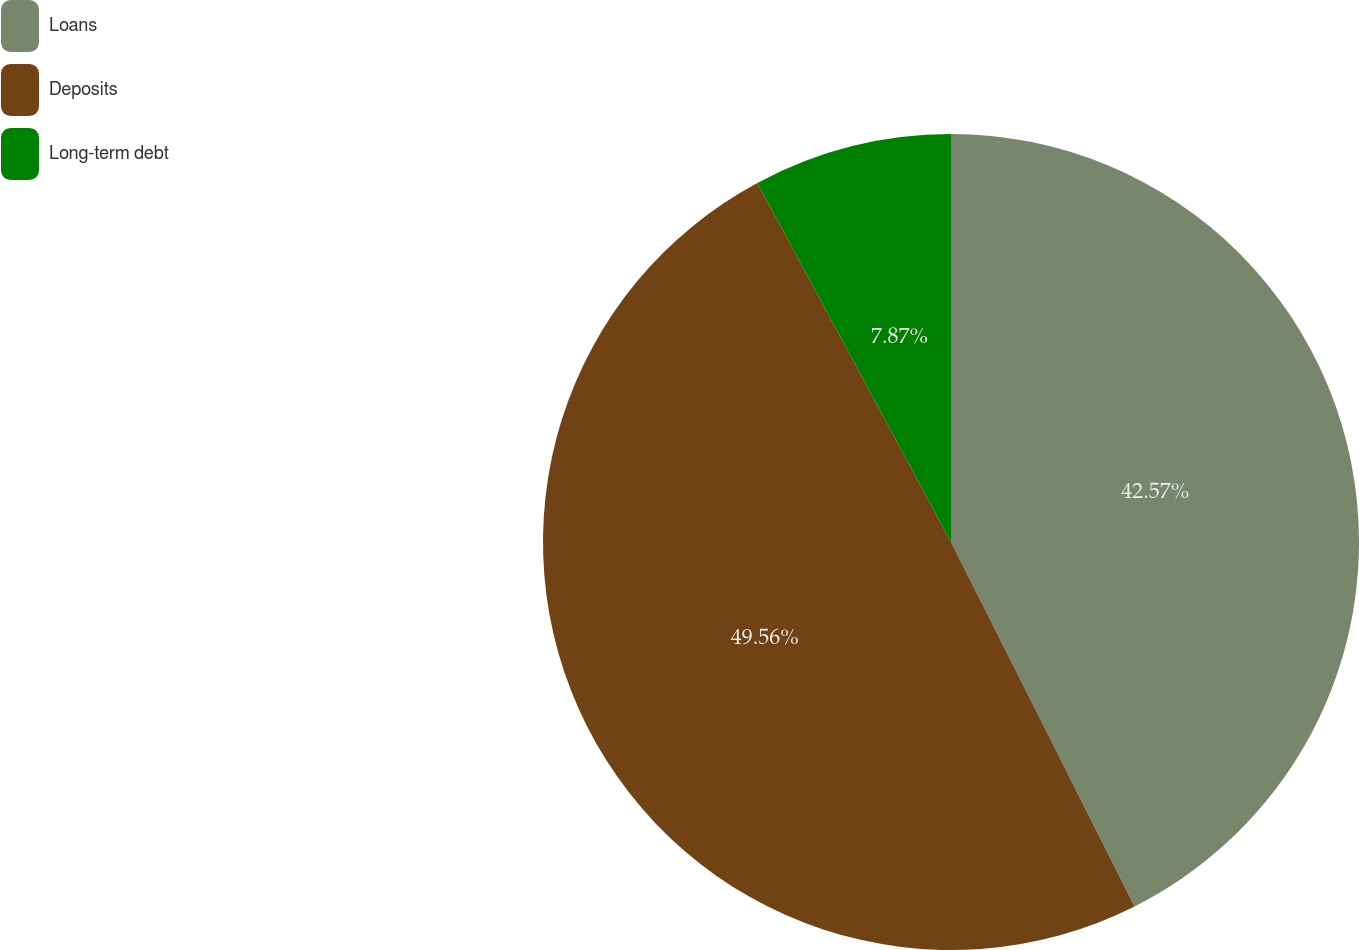Convert chart. <chart><loc_0><loc_0><loc_500><loc_500><pie_chart><fcel>Loans<fcel>Deposits<fcel>Long-term debt<nl><fcel>42.57%<fcel>49.55%<fcel>7.87%<nl></chart> 